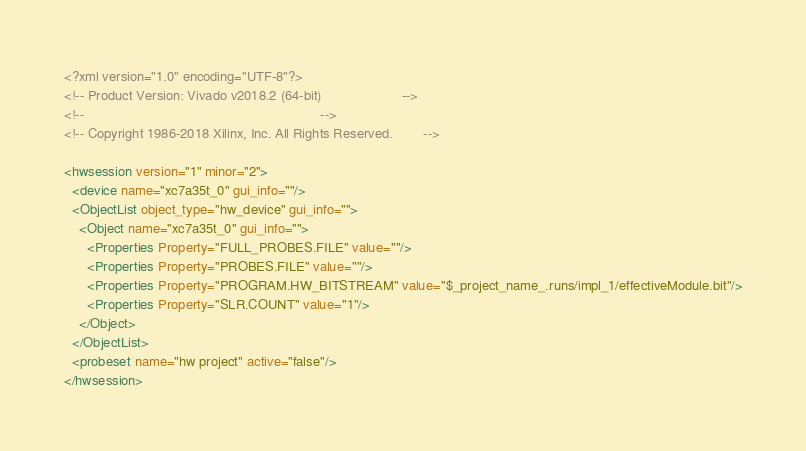<code> <loc_0><loc_0><loc_500><loc_500><_XML_><?xml version="1.0" encoding="UTF-8"?>
<!-- Product Version: Vivado v2018.2 (64-bit)                     -->
<!--                                                              -->
<!-- Copyright 1986-2018 Xilinx, Inc. All Rights Reserved.        -->

<hwsession version="1" minor="2">
  <device name="xc7a35t_0" gui_info=""/>
  <ObjectList object_type="hw_device" gui_info="">
    <Object name="xc7a35t_0" gui_info="">
      <Properties Property="FULL_PROBES.FILE" value=""/>
      <Properties Property="PROBES.FILE" value=""/>
      <Properties Property="PROGRAM.HW_BITSTREAM" value="$_project_name_.runs/impl_1/effectiveModule.bit"/>
      <Properties Property="SLR.COUNT" value="1"/>
    </Object>
  </ObjectList>
  <probeset name="hw project" active="false"/>
</hwsession>
</code> 